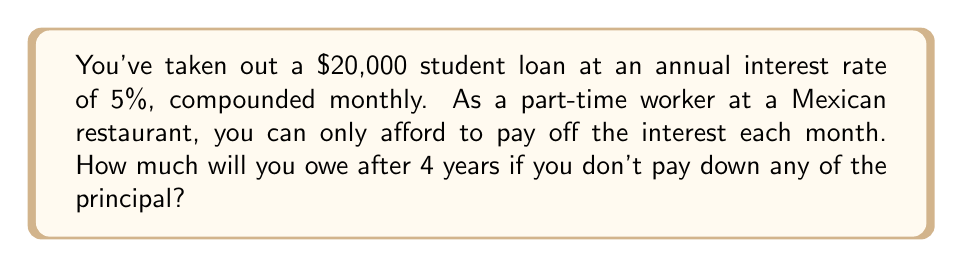Give your solution to this math problem. Let's approach this step-by-step:

1) The formula for compound interest is:
   
   $$A = P(1 + \frac{r}{n})^{nt}$$

   Where:
   $A$ = final amount
   $P$ = principal balance
   $r$ = annual interest rate (in decimal form)
   $n$ = number of times interest is compounded per year
   $t$ = number of years

2) Given:
   $P = 20,000$
   $r = 0.05$ (5% expressed as a decimal)
   $n = 12$ (compounded monthly)
   $t = 4$ years

3) Let's plug these values into the formula:

   $$A = 20,000(1 + \frac{0.05}{12})^{12 * 4}$$

4) Simplify inside the parentheses:

   $$A = 20,000(1 + 0.004167)^{48}$$

5) Calculate the exponent:

   $$A = 20,000(1.004167)^{48}$$

6) Use a calculator to compute this:

   $$A = 20,000 * 1.2214 = 24,428$$

Therefore, after 4 years, you would owe $24,428.
Answer: $24,428 